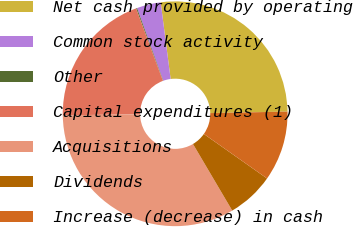Convert chart to OTSL. <chart><loc_0><loc_0><loc_500><loc_500><pie_chart><fcel>Net cash provided by operating<fcel>Common stock activity<fcel>Other<fcel>Capital expenditures (1)<fcel>Acquisitions<fcel>Dividends<fcel>Increase (decrease) in cash<nl><fcel>26.75%<fcel>3.45%<fcel>0.14%<fcel>19.57%<fcel>33.25%<fcel>6.76%<fcel>10.07%<nl></chart> 